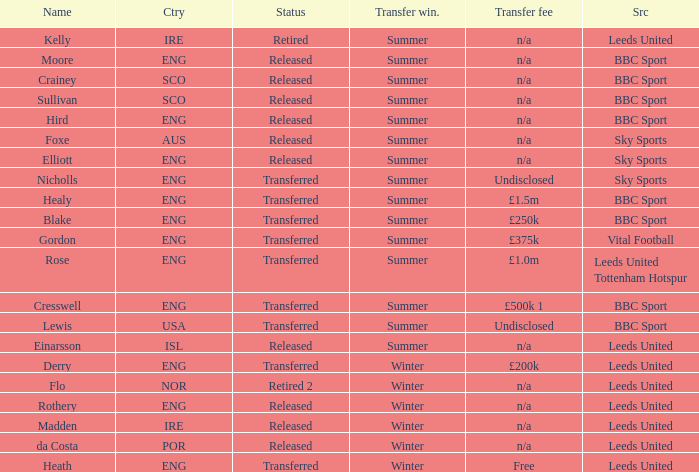What was the source of an ENG transfer that paid a £1.5m transfer fee? BBC Sport. 